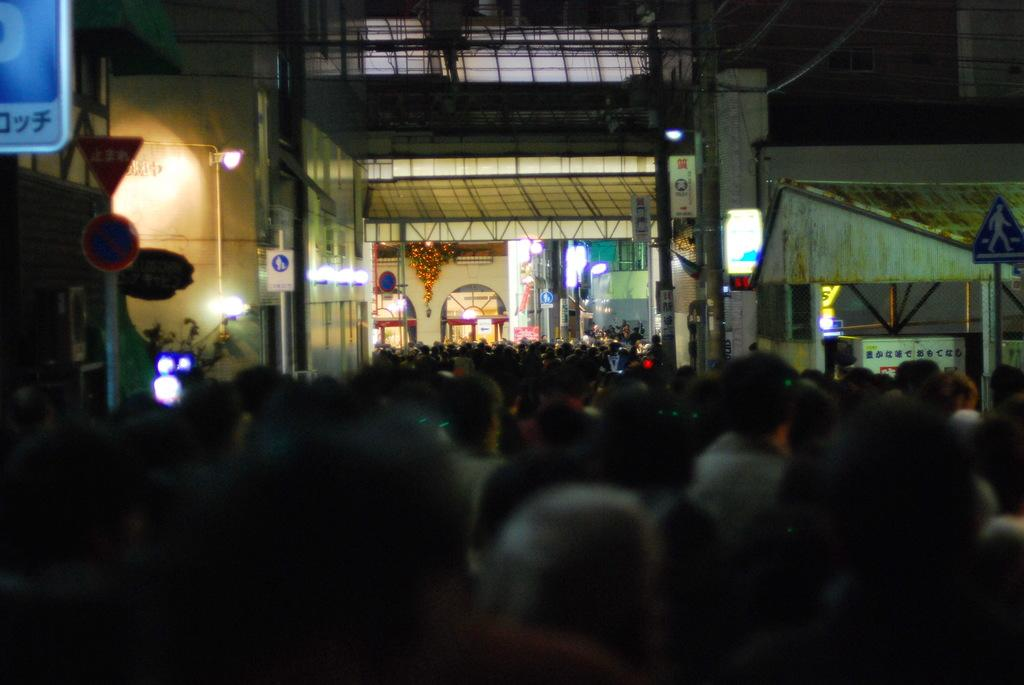What type of birds can be seen in the image? There are crows in the image. What structures are present in the image? There are poles, boards, and a building in the image. What additional features can be seen in the image? There are lights and a stall in the image. How much sugar is present in the wilderness depicted in the image? There is no wilderness depicted in the image, and therefore no sugar can be associated with it. 